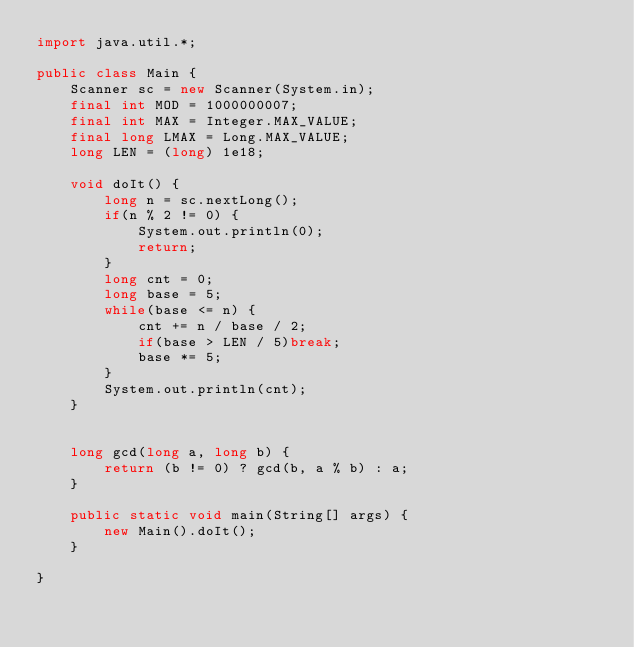<code> <loc_0><loc_0><loc_500><loc_500><_Java_>import java.util.*;

public class Main {
	Scanner sc = new Scanner(System.in);
	final int MOD = 1000000007;
	final int MAX = Integer.MAX_VALUE;
	final long LMAX = Long.MAX_VALUE;
	long LEN = (long) 1e18;
	
	void doIt() {
		long n = sc.nextLong();
		if(n % 2 != 0) {
			System.out.println(0);
			return;
		}
		long cnt = 0;
		long base = 5;
		while(base <= n) {
			cnt += n / base / 2;
			if(base > LEN / 5)break;
			base *= 5;
		}
		System.out.println(cnt);
	}
	

	long gcd(long a, long b) {
		return (b != 0) ? gcd(b, a % b) : a;
	}
	
	public static void main(String[] args) {
		new Main().doIt();
	}
	
}
</code> 